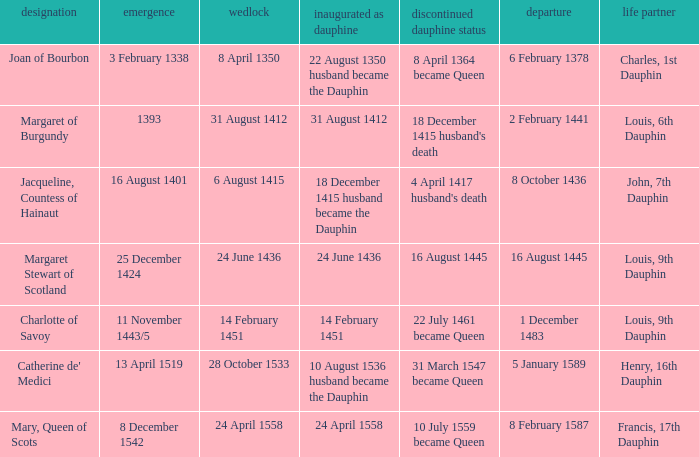When was became dauphine when birth is 1393? 31 August 1412. 